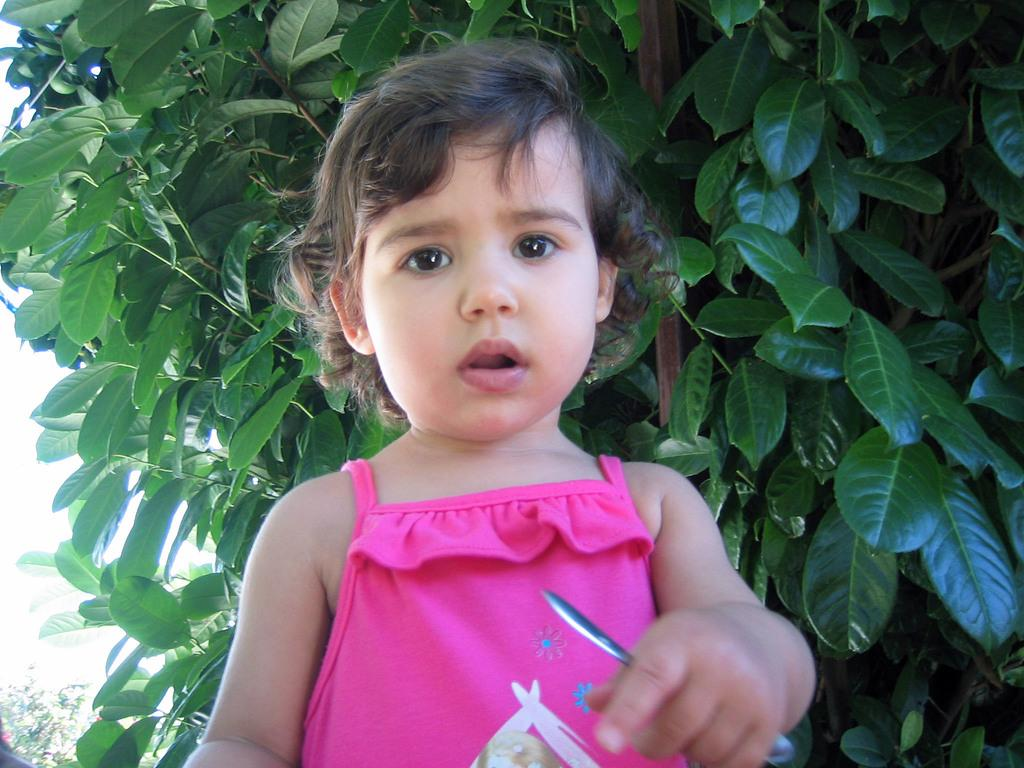What is the main subject of the picture? The main subject of the picture is a child. What can be seen in the background of the picture? There are plants in the background of the picture. What type of alarm is ringing in the background of the picture? There is no alarm present in the image; it only features a child and plants in the background. 